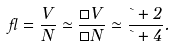Convert formula to latex. <formula><loc_0><loc_0><loc_500><loc_500>\gamma = \frac { V } { N } \simeq \frac { \Box V } { \Box N } \simeq \frac { \theta + 2 } { \theta + 4 } .</formula> 